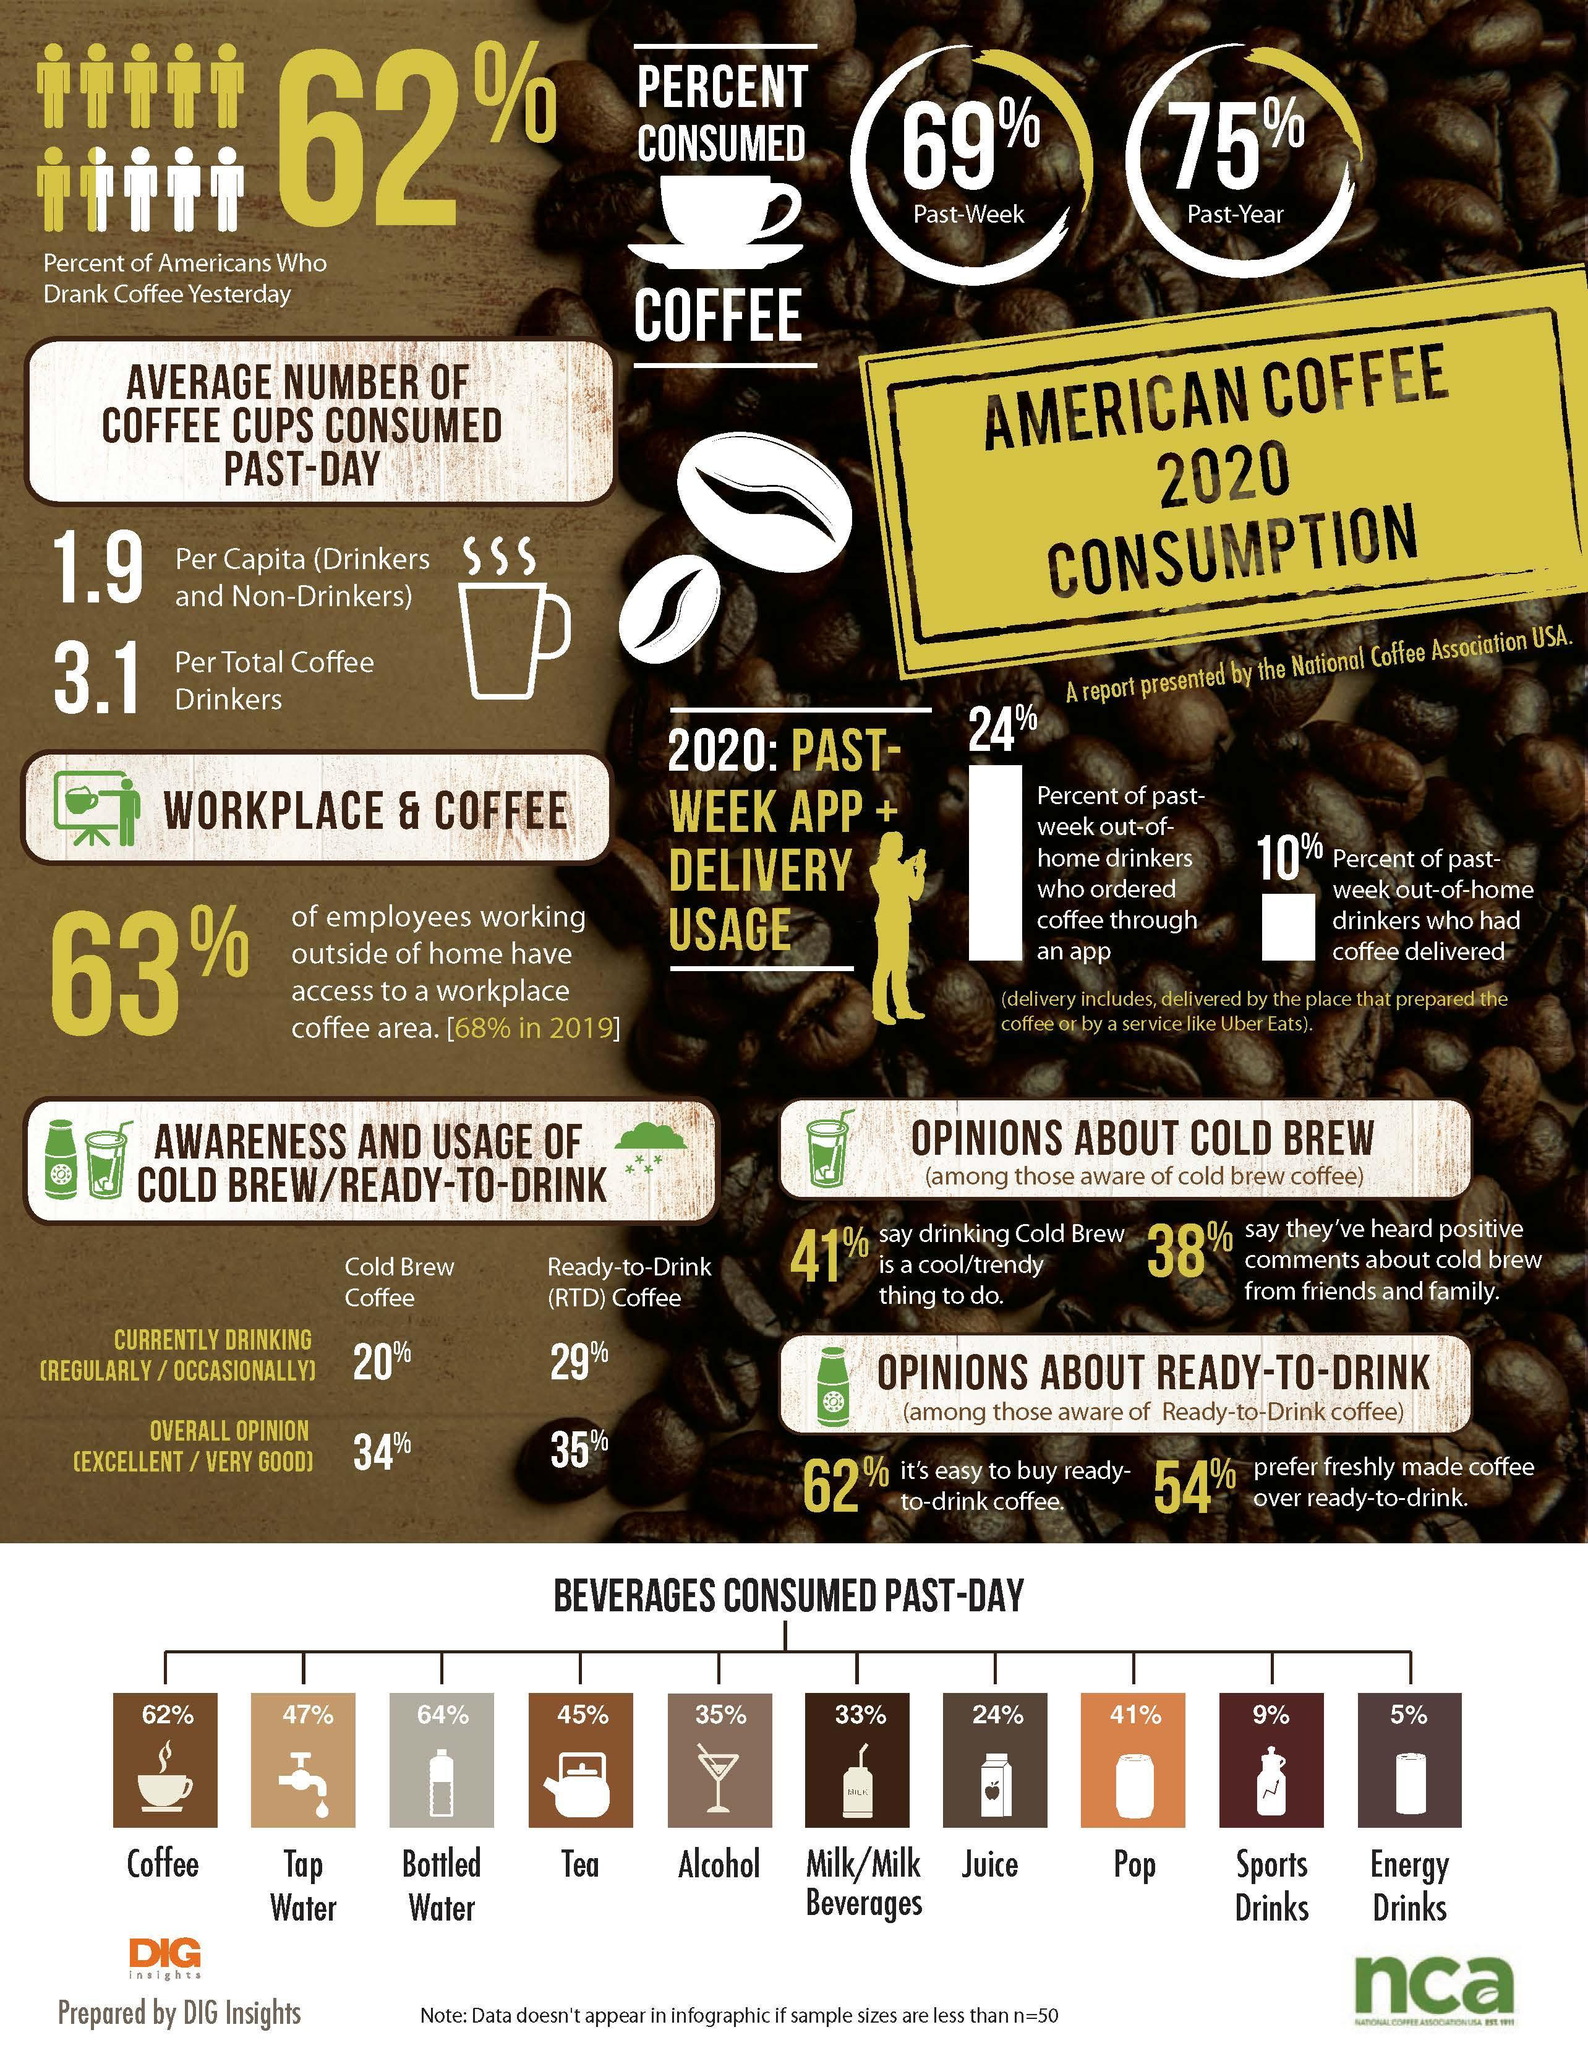What percent of Americans consumed coffee in 2019?
Answer the question with a short phrase. 75% What percent of Americans use cold coffee brew regularly or occasionally in 2020? 20% What percent of Americans consumed coffee in the past week in 2020? 69% Which beverage is least consumed by the Americans in the past day in 2020? Energy Drinks What percent of alcohol were consumed by the Americans in the past day in 2020? 35% What percent of American employees working outside of home do not have access to a workplace coffee area in 2020? 37% Which beverage is consumed by majority of the American in the past day in 2020? Coffee 